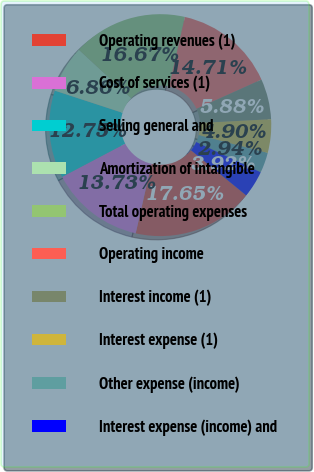<chart> <loc_0><loc_0><loc_500><loc_500><pie_chart><fcel>Operating revenues (1)<fcel>Cost of services (1)<fcel>Selling general and<fcel>Amortization of intangible<fcel>Total operating expenses<fcel>Operating income<fcel>Interest income (1)<fcel>Interest expense (1)<fcel>Other expense (income)<fcel>Interest expense (income) and<nl><fcel>17.65%<fcel>13.73%<fcel>12.75%<fcel>6.86%<fcel>16.67%<fcel>14.71%<fcel>5.88%<fcel>4.9%<fcel>2.94%<fcel>3.92%<nl></chart> 